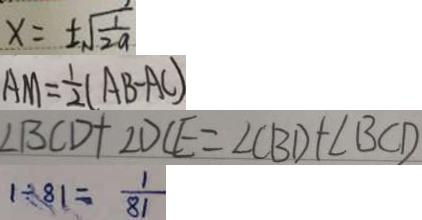Convert formula to latex. <formula><loc_0><loc_0><loc_500><loc_500>x = \pm \sqrt { \frac { 1 } { 2 a } } 
 A M = \frac { 1 } { 2 } ( A B - A C ) 
 \angle B C D + \angle D C E = \angle C B D + \angle B C D 
 1 \div 8 1 = \frac { 1 } { 8 1 }</formula> 